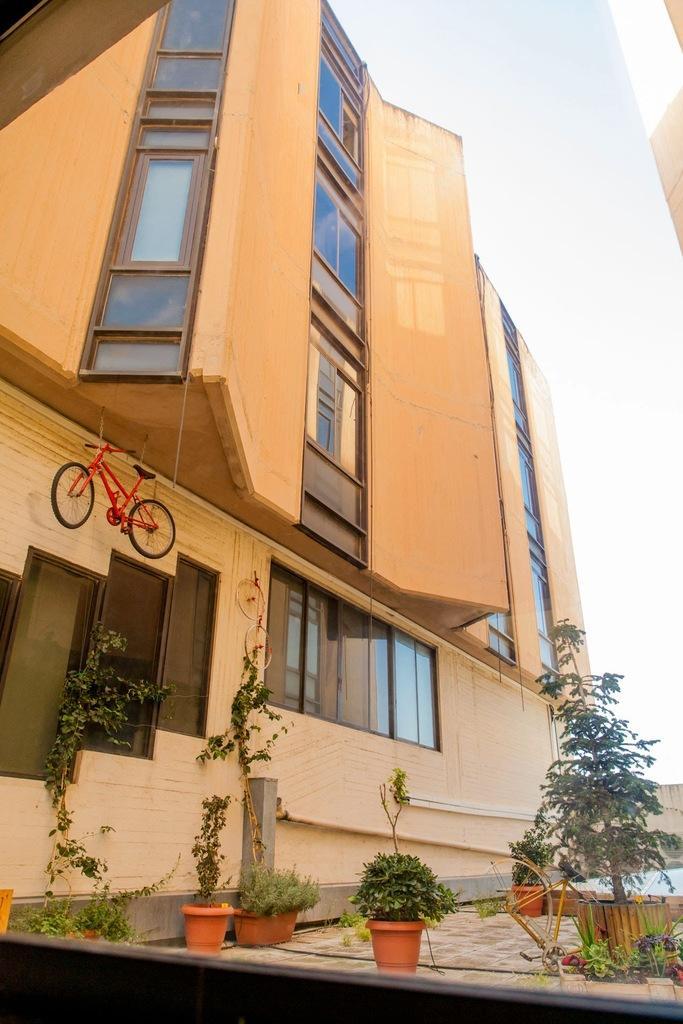Could you give a brief overview of what you see in this image? In this image we can see a building a bicycle, windows, trees, plants and sky. 